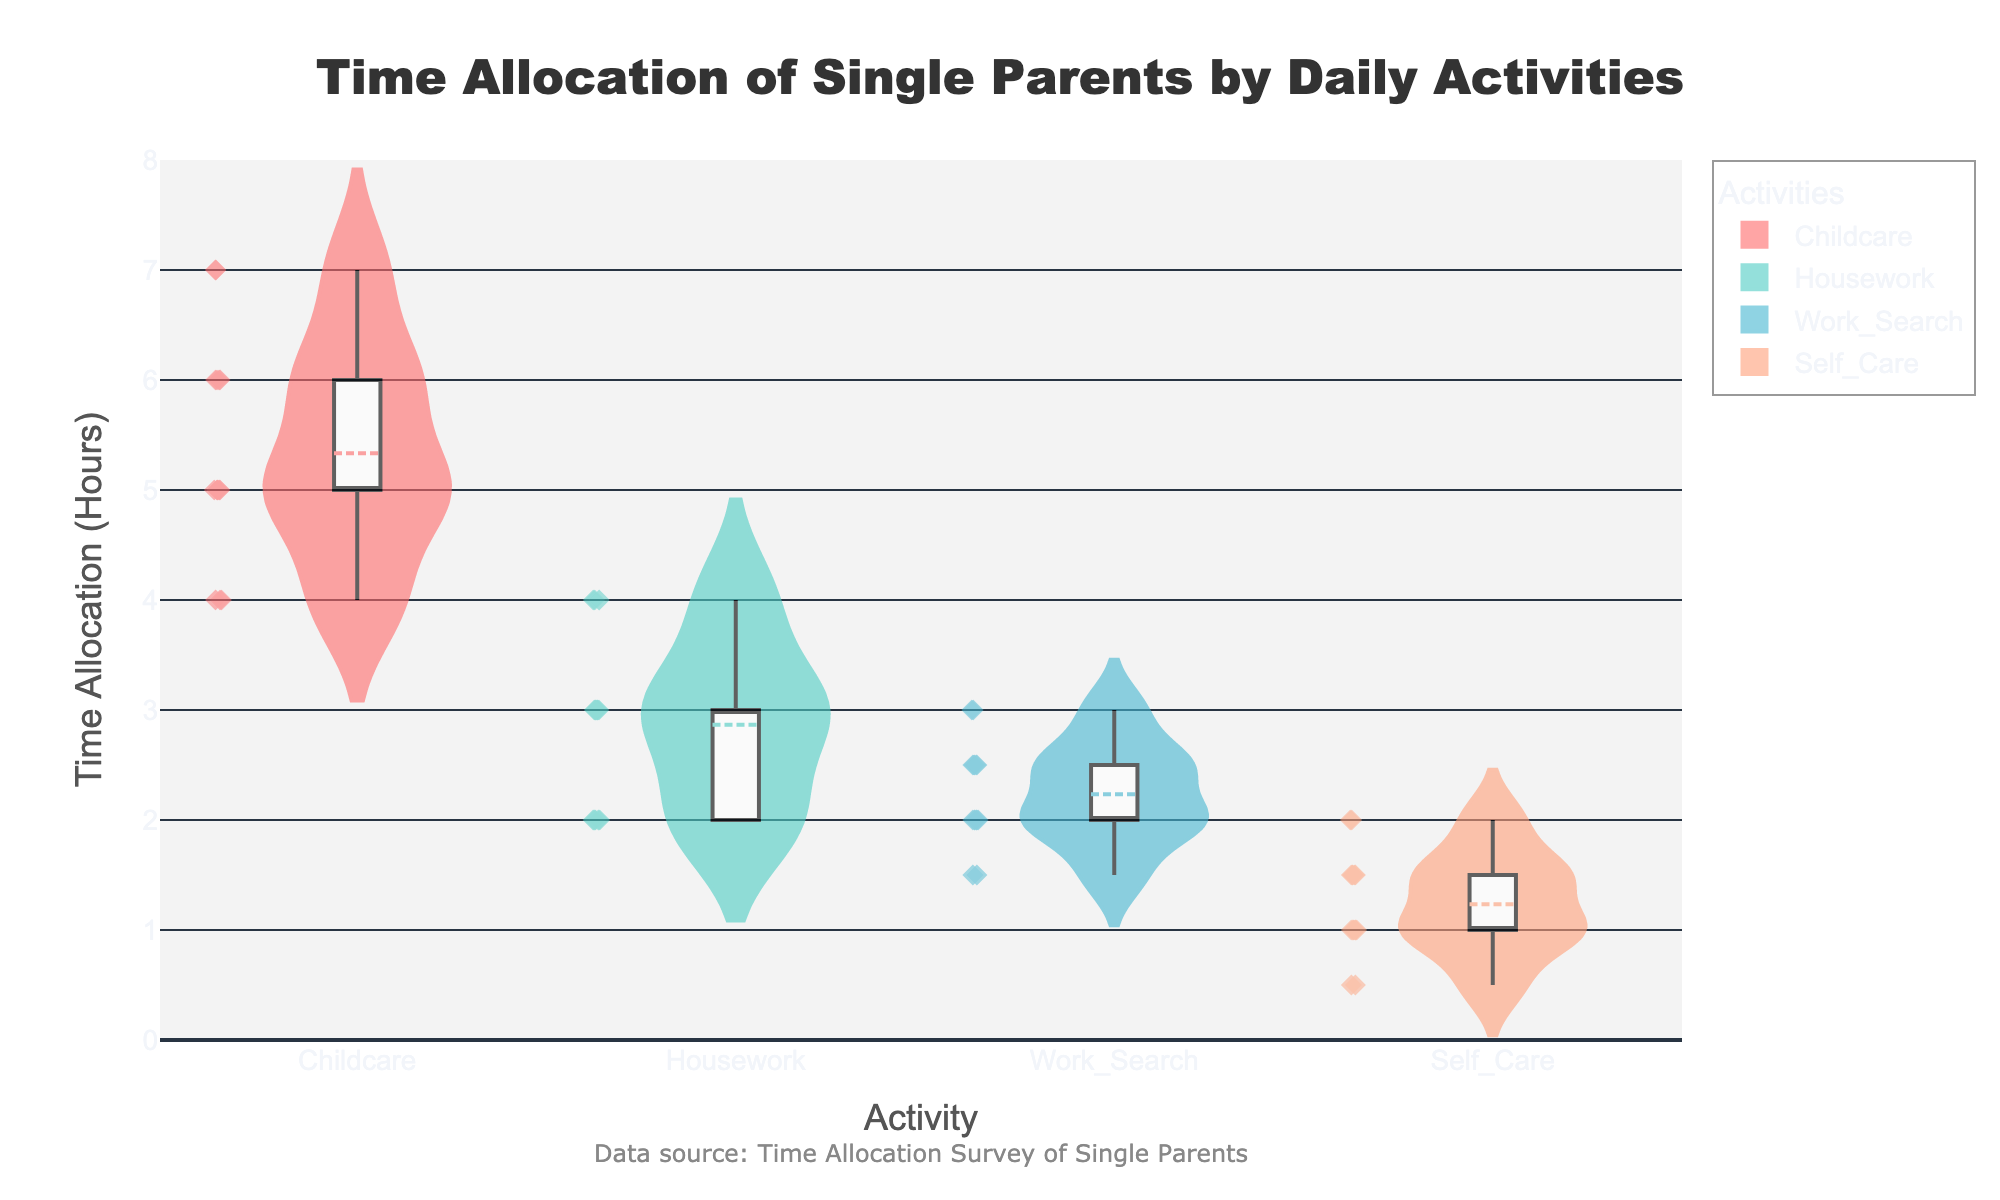What's the title of the chart? The title of the chart is generally displayed at the top of the figure. In this case, it is stated in the provided code as "Time Allocation of Single Parents by Daily Activities".
Answer: Time Allocation of Single Parents by Daily Activities How many activities are represented in the chart? The number of unique activities can be identified by counting the different named sections on the x-axis. The chart represents the activities "Childcare", "Housework", "Work Search", and "Self Care".
Answer: 4 Which activity shows the highest median time allocation? By examining the box plot overlaid on the violin plots, the thick central line inside each box represents the median. Comparing these medians across all activities, "Childcare" has the highest median time allocation.
Answer: Childcare Which activity has the most spread in time allocation? The spread refers to the range of time allocation values for an activity. This can be seen by comparing the widths of the violins. "Childcare" has the widest violin, suggesting the most variability in time allocation.
Answer: Childcare What is the median time spent on Housework? The central line inside the white box of the "Housework" violin plot indicates the median. For "Housework," this line is at 3 hours.
Answer: 3 hours What activity has the lowest maximum value of time allocation? The maximum value can be seen at the top of the violin plot. For "Self Care," the topmost point is at 2 hours, which is the lowest maximum value among all activities.
Answer: Self Care Which activity has the smallest interquartile range (IQR)? The IQR is the range within the box in the box plot. The box is smallest for "Work Search," indicating the smallest IQR.
Answer: Work Search Do all activities have the same number of data points? By observing the scattered points within each violin plot, it can be seen that each activity has a different number of visible points. Therefore, not all activities have the same number of data points.
Answer: No In which activity is the mean value and median value nearly the same? The mean is represented by a dashed line in the viollin plot, while the median is a solid line in the box plot. For "Work Search," the mean and median values are very close to each other.
Answer: Work Search 